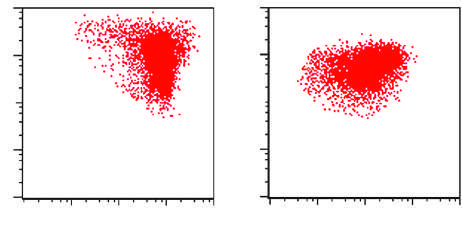does acute rheumatic mitral valvulitis result for the all shown in the figure?
Answer the question using a single word or phrase. No 